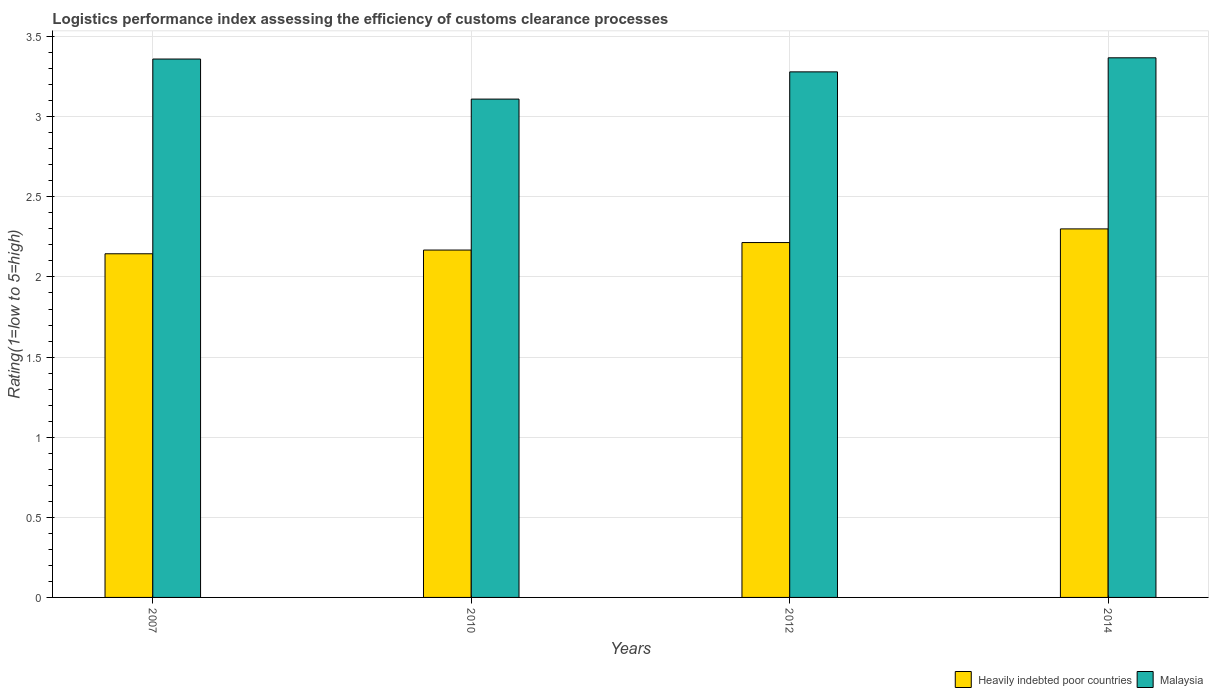How many different coloured bars are there?
Provide a succinct answer. 2. How many groups of bars are there?
Your response must be concise. 4. Are the number of bars per tick equal to the number of legend labels?
Give a very brief answer. Yes. Are the number of bars on each tick of the X-axis equal?
Keep it short and to the point. Yes. How many bars are there on the 3rd tick from the right?
Make the answer very short. 2. What is the label of the 3rd group of bars from the left?
Offer a very short reply. 2012. In how many cases, is the number of bars for a given year not equal to the number of legend labels?
Your answer should be compact. 0. What is the Logistic performance index in Heavily indebted poor countries in 2012?
Give a very brief answer. 2.21. Across all years, what is the maximum Logistic performance index in Malaysia?
Offer a terse response. 3.37. Across all years, what is the minimum Logistic performance index in Heavily indebted poor countries?
Ensure brevity in your answer.  2.14. In which year was the Logistic performance index in Heavily indebted poor countries minimum?
Ensure brevity in your answer.  2007. What is the total Logistic performance index in Malaysia in the graph?
Give a very brief answer. 13.12. What is the difference between the Logistic performance index in Heavily indebted poor countries in 2007 and that in 2010?
Ensure brevity in your answer.  -0.02. What is the difference between the Logistic performance index in Malaysia in 2007 and the Logistic performance index in Heavily indebted poor countries in 2014?
Provide a short and direct response. 1.06. What is the average Logistic performance index in Heavily indebted poor countries per year?
Give a very brief answer. 2.21. In the year 2007, what is the difference between the Logistic performance index in Heavily indebted poor countries and Logistic performance index in Malaysia?
Your answer should be very brief. -1.22. What is the ratio of the Logistic performance index in Malaysia in 2007 to that in 2010?
Keep it short and to the point. 1.08. Is the difference between the Logistic performance index in Heavily indebted poor countries in 2010 and 2014 greater than the difference between the Logistic performance index in Malaysia in 2010 and 2014?
Your answer should be very brief. Yes. What is the difference between the highest and the second highest Logistic performance index in Heavily indebted poor countries?
Provide a succinct answer. 0.09. What is the difference between the highest and the lowest Logistic performance index in Malaysia?
Keep it short and to the point. 0.26. What does the 1st bar from the left in 2007 represents?
Keep it short and to the point. Heavily indebted poor countries. What does the 1st bar from the right in 2007 represents?
Your answer should be very brief. Malaysia. How many years are there in the graph?
Ensure brevity in your answer.  4. What is the difference between two consecutive major ticks on the Y-axis?
Give a very brief answer. 0.5. Are the values on the major ticks of Y-axis written in scientific E-notation?
Offer a terse response. No. Does the graph contain any zero values?
Your response must be concise. No. Where does the legend appear in the graph?
Offer a terse response. Bottom right. How many legend labels are there?
Give a very brief answer. 2. How are the legend labels stacked?
Provide a short and direct response. Horizontal. What is the title of the graph?
Make the answer very short. Logistics performance index assessing the efficiency of customs clearance processes. What is the label or title of the Y-axis?
Your answer should be very brief. Rating(1=low to 5=high). What is the Rating(1=low to 5=high) of Heavily indebted poor countries in 2007?
Provide a short and direct response. 2.14. What is the Rating(1=low to 5=high) in Malaysia in 2007?
Keep it short and to the point. 3.36. What is the Rating(1=low to 5=high) in Heavily indebted poor countries in 2010?
Offer a terse response. 2.17. What is the Rating(1=low to 5=high) of Malaysia in 2010?
Offer a very short reply. 3.11. What is the Rating(1=low to 5=high) of Heavily indebted poor countries in 2012?
Provide a short and direct response. 2.21. What is the Rating(1=low to 5=high) of Malaysia in 2012?
Your answer should be very brief. 3.28. What is the Rating(1=low to 5=high) of Heavily indebted poor countries in 2014?
Ensure brevity in your answer.  2.3. What is the Rating(1=low to 5=high) in Malaysia in 2014?
Give a very brief answer. 3.37. Across all years, what is the maximum Rating(1=low to 5=high) in Heavily indebted poor countries?
Provide a short and direct response. 2.3. Across all years, what is the maximum Rating(1=low to 5=high) of Malaysia?
Your answer should be very brief. 3.37. Across all years, what is the minimum Rating(1=low to 5=high) of Heavily indebted poor countries?
Your answer should be compact. 2.14. Across all years, what is the minimum Rating(1=low to 5=high) of Malaysia?
Make the answer very short. 3.11. What is the total Rating(1=low to 5=high) of Heavily indebted poor countries in the graph?
Your answer should be compact. 8.83. What is the total Rating(1=low to 5=high) in Malaysia in the graph?
Give a very brief answer. 13.12. What is the difference between the Rating(1=low to 5=high) of Heavily indebted poor countries in 2007 and that in 2010?
Offer a terse response. -0.02. What is the difference between the Rating(1=low to 5=high) of Malaysia in 2007 and that in 2010?
Your answer should be compact. 0.25. What is the difference between the Rating(1=low to 5=high) of Heavily indebted poor countries in 2007 and that in 2012?
Offer a terse response. -0.07. What is the difference between the Rating(1=low to 5=high) of Malaysia in 2007 and that in 2012?
Keep it short and to the point. 0.08. What is the difference between the Rating(1=low to 5=high) in Heavily indebted poor countries in 2007 and that in 2014?
Make the answer very short. -0.16. What is the difference between the Rating(1=low to 5=high) of Malaysia in 2007 and that in 2014?
Give a very brief answer. -0.01. What is the difference between the Rating(1=low to 5=high) in Heavily indebted poor countries in 2010 and that in 2012?
Provide a short and direct response. -0.05. What is the difference between the Rating(1=low to 5=high) in Malaysia in 2010 and that in 2012?
Your answer should be very brief. -0.17. What is the difference between the Rating(1=low to 5=high) of Heavily indebted poor countries in 2010 and that in 2014?
Provide a succinct answer. -0.13. What is the difference between the Rating(1=low to 5=high) of Malaysia in 2010 and that in 2014?
Offer a terse response. -0.26. What is the difference between the Rating(1=low to 5=high) of Heavily indebted poor countries in 2012 and that in 2014?
Offer a very short reply. -0.09. What is the difference between the Rating(1=low to 5=high) of Malaysia in 2012 and that in 2014?
Keep it short and to the point. -0.09. What is the difference between the Rating(1=low to 5=high) in Heavily indebted poor countries in 2007 and the Rating(1=low to 5=high) in Malaysia in 2010?
Keep it short and to the point. -0.97. What is the difference between the Rating(1=low to 5=high) of Heavily indebted poor countries in 2007 and the Rating(1=low to 5=high) of Malaysia in 2012?
Ensure brevity in your answer.  -1.14. What is the difference between the Rating(1=low to 5=high) in Heavily indebted poor countries in 2007 and the Rating(1=low to 5=high) in Malaysia in 2014?
Your answer should be very brief. -1.22. What is the difference between the Rating(1=low to 5=high) in Heavily indebted poor countries in 2010 and the Rating(1=low to 5=high) in Malaysia in 2012?
Your answer should be very brief. -1.11. What is the difference between the Rating(1=low to 5=high) of Heavily indebted poor countries in 2010 and the Rating(1=low to 5=high) of Malaysia in 2014?
Keep it short and to the point. -1.2. What is the difference between the Rating(1=low to 5=high) of Heavily indebted poor countries in 2012 and the Rating(1=low to 5=high) of Malaysia in 2014?
Offer a terse response. -1.15. What is the average Rating(1=low to 5=high) in Heavily indebted poor countries per year?
Ensure brevity in your answer.  2.21. What is the average Rating(1=low to 5=high) in Malaysia per year?
Offer a very short reply. 3.28. In the year 2007, what is the difference between the Rating(1=low to 5=high) of Heavily indebted poor countries and Rating(1=low to 5=high) of Malaysia?
Your answer should be compact. -1.22. In the year 2010, what is the difference between the Rating(1=low to 5=high) of Heavily indebted poor countries and Rating(1=low to 5=high) of Malaysia?
Offer a terse response. -0.94. In the year 2012, what is the difference between the Rating(1=low to 5=high) in Heavily indebted poor countries and Rating(1=low to 5=high) in Malaysia?
Ensure brevity in your answer.  -1.07. In the year 2014, what is the difference between the Rating(1=low to 5=high) of Heavily indebted poor countries and Rating(1=low to 5=high) of Malaysia?
Your response must be concise. -1.07. What is the ratio of the Rating(1=low to 5=high) in Heavily indebted poor countries in 2007 to that in 2010?
Keep it short and to the point. 0.99. What is the ratio of the Rating(1=low to 5=high) of Malaysia in 2007 to that in 2010?
Give a very brief answer. 1.08. What is the ratio of the Rating(1=low to 5=high) of Heavily indebted poor countries in 2007 to that in 2012?
Make the answer very short. 0.97. What is the ratio of the Rating(1=low to 5=high) of Malaysia in 2007 to that in 2012?
Your answer should be compact. 1.02. What is the ratio of the Rating(1=low to 5=high) in Heavily indebted poor countries in 2007 to that in 2014?
Offer a very short reply. 0.93. What is the ratio of the Rating(1=low to 5=high) of Malaysia in 2007 to that in 2014?
Offer a terse response. 1. What is the ratio of the Rating(1=low to 5=high) in Heavily indebted poor countries in 2010 to that in 2012?
Give a very brief answer. 0.98. What is the ratio of the Rating(1=low to 5=high) of Malaysia in 2010 to that in 2012?
Offer a terse response. 0.95. What is the ratio of the Rating(1=low to 5=high) in Heavily indebted poor countries in 2010 to that in 2014?
Your response must be concise. 0.94. What is the ratio of the Rating(1=low to 5=high) of Malaysia in 2010 to that in 2014?
Keep it short and to the point. 0.92. What is the ratio of the Rating(1=low to 5=high) of Heavily indebted poor countries in 2012 to that in 2014?
Provide a succinct answer. 0.96. What is the difference between the highest and the second highest Rating(1=low to 5=high) of Heavily indebted poor countries?
Keep it short and to the point. 0.09. What is the difference between the highest and the second highest Rating(1=low to 5=high) of Malaysia?
Provide a short and direct response. 0.01. What is the difference between the highest and the lowest Rating(1=low to 5=high) of Heavily indebted poor countries?
Offer a terse response. 0.16. What is the difference between the highest and the lowest Rating(1=low to 5=high) in Malaysia?
Offer a very short reply. 0.26. 